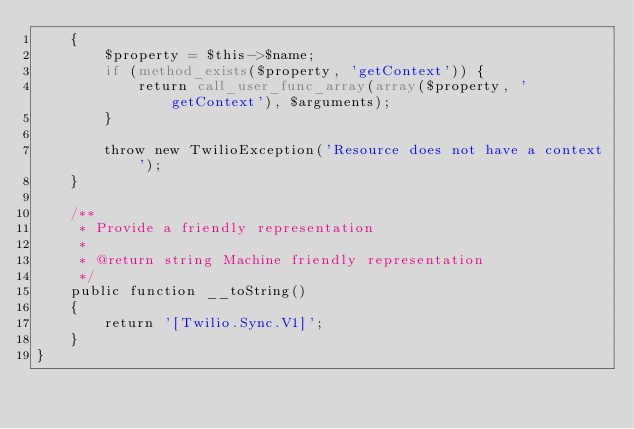<code> <loc_0><loc_0><loc_500><loc_500><_PHP_>    {
        $property = $this->$name;
        if (method_exists($property, 'getContext')) {
            return call_user_func_array(array($property, 'getContext'), $arguments);
        }

        throw new TwilioException('Resource does not have a context');
    }

    /**
     * Provide a friendly representation
     *
     * @return string Machine friendly representation
     */
    public function __toString()
    {
        return '[Twilio.Sync.V1]';
    }
}</code> 